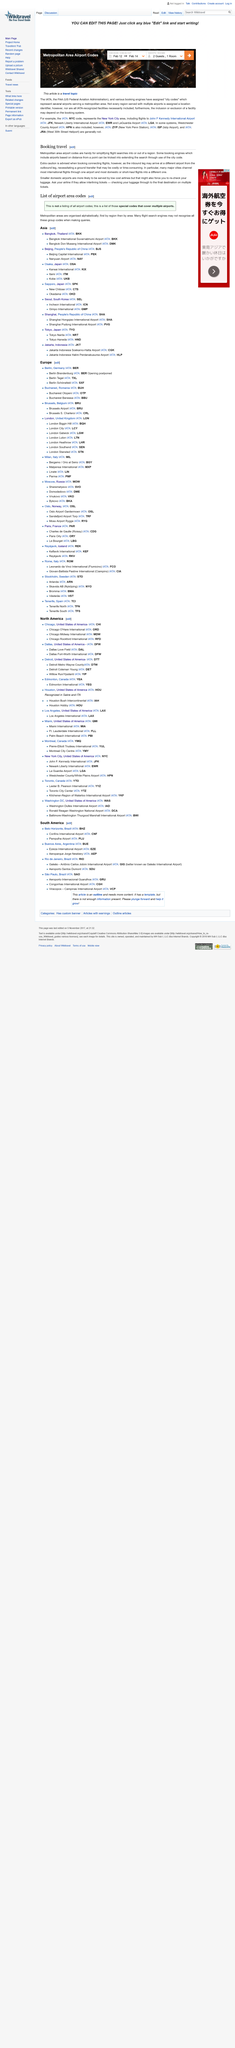Identify some key points in this picture. During the booking process for travel, there may be issues that arise related to connecting flights, such as the need for ground transfers, which could result in additional costs or delays. Smaller domestic airports, in general, are more likely to be served by low cost airlines than larger airports. Yes, metropolitan area airport codes are very useful when booking travel. 